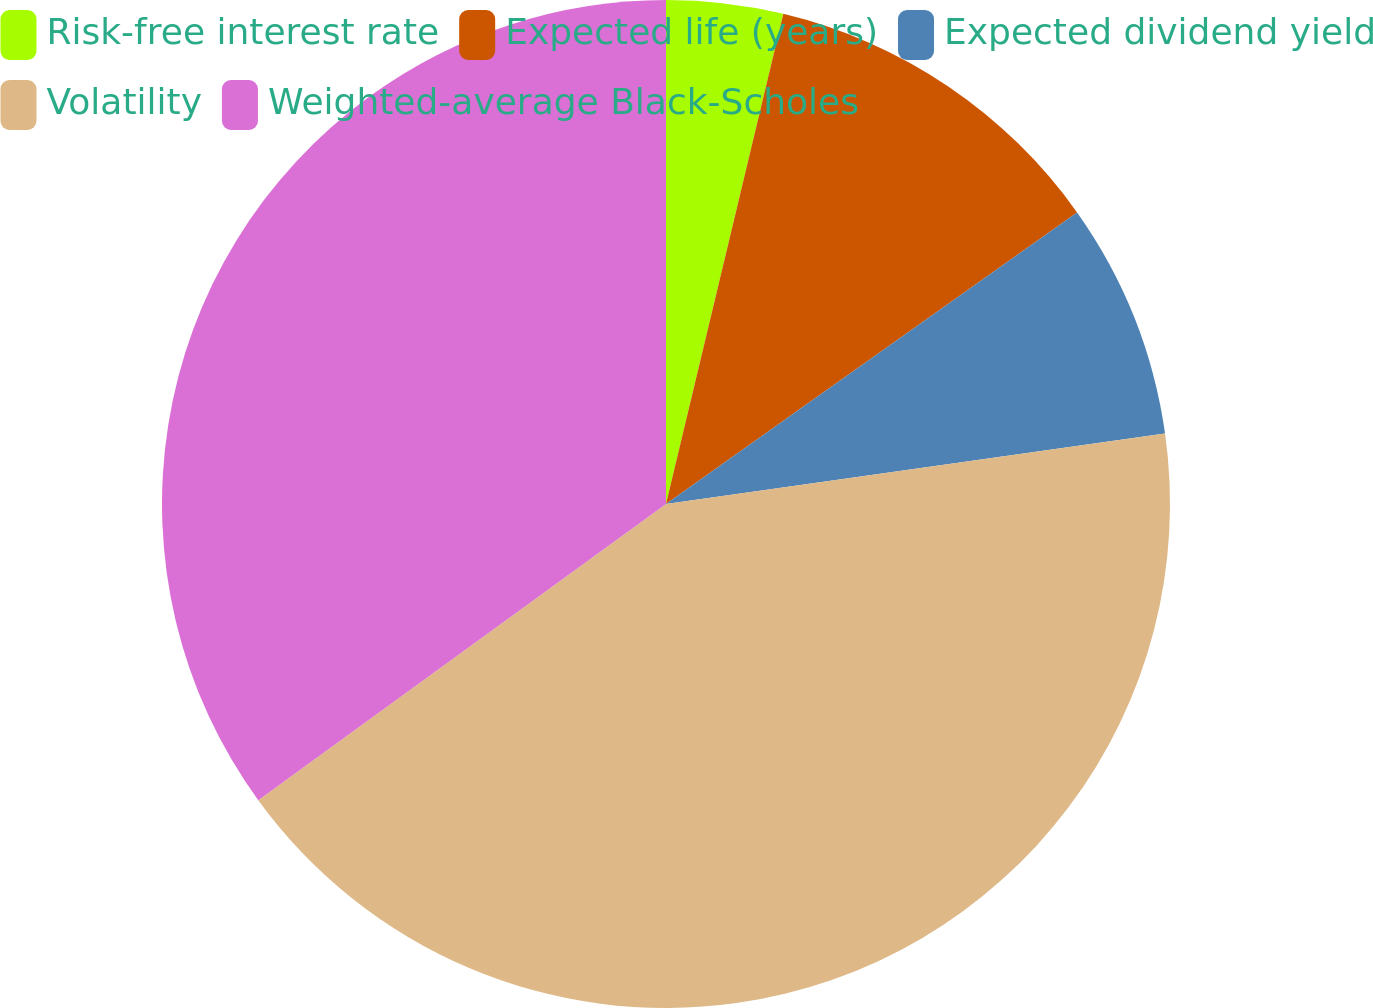<chart> <loc_0><loc_0><loc_500><loc_500><pie_chart><fcel>Risk-free interest rate<fcel>Expected life (years)<fcel>Expected dividend yield<fcel>Volatility<fcel>Weighted-average Black-Scholes<nl><fcel>3.74%<fcel>11.44%<fcel>7.59%<fcel>42.23%<fcel>35.0%<nl></chart> 